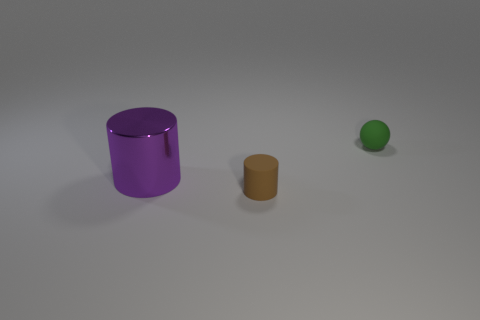Add 1 tiny things. How many objects exist? 4 Subtract all spheres. How many objects are left? 2 Add 1 matte spheres. How many matte spheres are left? 2 Add 2 small purple things. How many small purple things exist? 2 Subtract 0 cyan cylinders. How many objects are left? 3 Subtract all tiny brown cylinders. Subtract all large things. How many objects are left? 1 